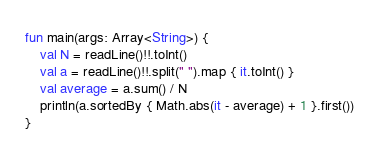<code> <loc_0><loc_0><loc_500><loc_500><_Kotlin_>fun main(args: Array<String>) {
    val N = readLine()!!.toInt()
    val a = readLine()!!.split(" ").map { it.toInt() }
    val average = a.sum() / N
    println(a.sortedBy { Math.abs(it - average) + 1 }.first())
}</code> 